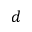Convert formula to latex. <formula><loc_0><loc_0><loc_500><loc_500>d</formula> 